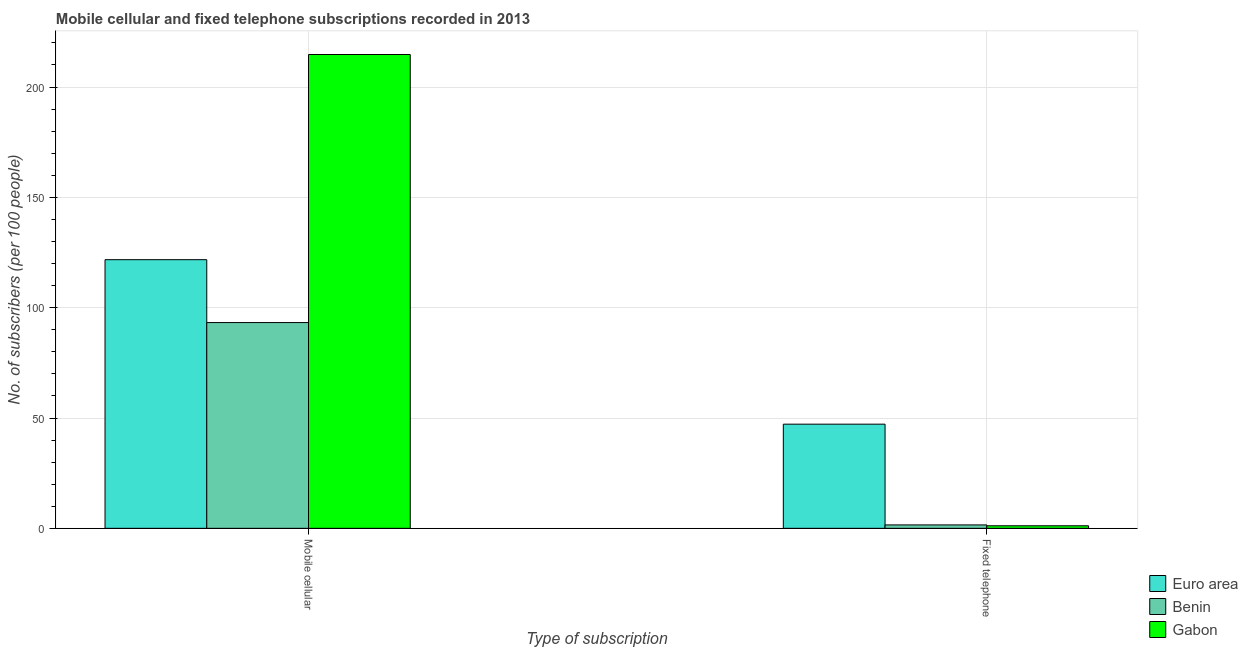Are the number of bars per tick equal to the number of legend labels?
Give a very brief answer. Yes. Are the number of bars on each tick of the X-axis equal?
Provide a short and direct response. Yes. How many bars are there on the 2nd tick from the left?
Your response must be concise. 3. What is the label of the 2nd group of bars from the left?
Provide a short and direct response. Fixed telephone. What is the number of fixed telephone subscribers in Benin?
Provide a short and direct response. 1.54. Across all countries, what is the maximum number of fixed telephone subscribers?
Provide a short and direct response. 47.21. Across all countries, what is the minimum number of fixed telephone subscribers?
Offer a terse response. 1.15. In which country was the number of fixed telephone subscribers maximum?
Your answer should be very brief. Euro area. In which country was the number of mobile cellular subscribers minimum?
Make the answer very short. Benin. What is the total number of fixed telephone subscribers in the graph?
Provide a short and direct response. 49.9. What is the difference between the number of mobile cellular subscribers in Gabon and that in Benin?
Your answer should be compact. 121.49. What is the difference between the number of fixed telephone subscribers in Gabon and the number of mobile cellular subscribers in Benin?
Keep it short and to the point. -92.11. What is the average number of mobile cellular subscribers per country?
Keep it short and to the point. 143.26. What is the difference between the number of mobile cellular subscribers and number of fixed telephone subscribers in Benin?
Offer a terse response. 91.71. What is the ratio of the number of mobile cellular subscribers in Benin to that in Gabon?
Offer a very short reply. 0.43. Is the number of fixed telephone subscribers in Gabon less than that in Euro area?
Keep it short and to the point. Yes. In how many countries, is the number of fixed telephone subscribers greater than the average number of fixed telephone subscribers taken over all countries?
Provide a succinct answer. 1. What does the 2nd bar from the left in Mobile cellular represents?
Your answer should be compact. Benin. What does the 2nd bar from the right in Fixed telephone represents?
Give a very brief answer. Benin. How many bars are there?
Ensure brevity in your answer.  6. What is the difference between two consecutive major ticks on the Y-axis?
Your answer should be compact. 50. Are the values on the major ticks of Y-axis written in scientific E-notation?
Provide a succinct answer. No. Does the graph contain any zero values?
Offer a very short reply. No. Where does the legend appear in the graph?
Your response must be concise. Bottom right. How are the legend labels stacked?
Provide a short and direct response. Vertical. What is the title of the graph?
Your answer should be very brief. Mobile cellular and fixed telephone subscriptions recorded in 2013. What is the label or title of the X-axis?
Your response must be concise. Type of subscription. What is the label or title of the Y-axis?
Keep it short and to the point. No. of subscribers (per 100 people). What is the No. of subscribers (per 100 people) in Euro area in Mobile cellular?
Ensure brevity in your answer.  121.76. What is the No. of subscribers (per 100 people) of Benin in Mobile cellular?
Your answer should be very brief. 93.26. What is the No. of subscribers (per 100 people) in Gabon in Mobile cellular?
Provide a succinct answer. 214.75. What is the No. of subscribers (per 100 people) in Euro area in Fixed telephone?
Provide a short and direct response. 47.21. What is the No. of subscribers (per 100 people) of Benin in Fixed telephone?
Offer a terse response. 1.54. What is the No. of subscribers (per 100 people) in Gabon in Fixed telephone?
Give a very brief answer. 1.15. Across all Type of subscription, what is the maximum No. of subscribers (per 100 people) of Euro area?
Your answer should be compact. 121.76. Across all Type of subscription, what is the maximum No. of subscribers (per 100 people) in Benin?
Ensure brevity in your answer.  93.26. Across all Type of subscription, what is the maximum No. of subscribers (per 100 people) in Gabon?
Your response must be concise. 214.75. Across all Type of subscription, what is the minimum No. of subscribers (per 100 people) in Euro area?
Provide a short and direct response. 47.21. Across all Type of subscription, what is the minimum No. of subscribers (per 100 people) of Benin?
Provide a succinct answer. 1.54. Across all Type of subscription, what is the minimum No. of subscribers (per 100 people) in Gabon?
Provide a short and direct response. 1.15. What is the total No. of subscribers (per 100 people) of Euro area in the graph?
Your answer should be compact. 168.96. What is the total No. of subscribers (per 100 people) of Benin in the graph?
Offer a terse response. 94.8. What is the total No. of subscribers (per 100 people) in Gabon in the graph?
Your answer should be very brief. 215.9. What is the difference between the No. of subscribers (per 100 people) of Euro area in Mobile cellular and that in Fixed telephone?
Offer a very short reply. 74.55. What is the difference between the No. of subscribers (per 100 people) of Benin in Mobile cellular and that in Fixed telephone?
Provide a succinct answer. 91.71. What is the difference between the No. of subscribers (per 100 people) of Gabon in Mobile cellular and that in Fixed telephone?
Keep it short and to the point. 213.6. What is the difference between the No. of subscribers (per 100 people) of Euro area in Mobile cellular and the No. of subscribers (per 100 people) of Benin in Fixed telephone?
Ensure brevity in your answer.  120.21. What is the difference between the No. of subscribers (per 100 people) in Euro area in Mobile cellular and the No. of subscribers (per 100 people) in Gabon in Fixed telephone?
Ensure brevity in your answer.  120.61. What is the difference between the No. of subscribers (per 100 people) of Benin in Mobile cellular and the No. of subscribers (per 100 people) of Gabon in Fixed telephone?
Your response must be concise. 92.11. What is the average No. of subscribers (per 100 people) of Euro area per Type of subscription?
Keep it short and to the point. 84.48. What is the average No. of subscribers (per 100 people) in Benin per Type of subscription?
Keep it short and to the point. 47.4. What is the average No. of subscribers (per 100 people) in Gabon per Type of subscription?
Ensure brevity in your answer.  107.95. What is the difference between the No. of subscribers (per 100 people) of Euro area and No. of subscribers (per 100 people) of Benin in Mobile cellular?
Make the answer very short. 28.5. What is the difference between the No. of subscribers (per 100 people) of Euro area and No. of subscribers (per 100 people) of Gabon in Mobile cellular?
Ensure brevity in your answer.  -92.99. What is the difference between the No. of subscribers (per 100 people) in Benin and No. of subscribers (per 100 people) in Gabon in Mobile cellular?
Your answer should be compact. -121.49. What is the difference between the No. of subscribers (per 100 people) of Euro area and No. of subscribers (per 100 people) of Benin in Fixed telephone?
Give a very brief answer. 45.66. What is the difference between the No. of subscribers (per 100 people) of Euro area and No. of subscribers (per 100 people) of Gabon in Fixed telephone?
Provide a short and direct response. 46.05. What is the difference between the No. of subscribers (per 100 people) in Benin and No. of subscribers (per 100 people) in Gabon in Fixed telephone?
Offer a terse response. 0.39. What is the ratio of the No. of subscribers (per 100 people) in Euro area in Mobile cellular to that in Fixed telephone?
Make the answer very short. 2.58. What is the ratio of the No. of subscribers (per 100 people) of Benin in Mobile cellular to that in Fixed telephone?
Provide a short and direct response. 60.38. What is the ratio of the No. of subscribers (per 100 people) in Gabon in Mobile cellular to that in Fixed telephone?
Offer a terse response. 186.47. What is the difference between the highest and the second highest No. of subscribers (per 100 people) of Euro area?
Provide a succinct answer. 74.55. What is the difference between the highest and the second highest No. of subscribers (per 100 people) of Benin?
Your answer should be compact. 91.71. What is the difference between the highest and the second highest No. of subscribers (per 100 people) in Gabon?
Offer a very short reply. 213.6. What is the difference between the highest and the lowest No. of subscribers (per 100 people) of Euro area?
Give a very brief answer. 74.55. What is the difference between the highest and the lowest No. of subscribers (per 100 people) of Benin?
Keep it short and to the point. 91.71. What is the difference between the highest and the lowest No. of subscribers (per 100 people) of Gabon?
Your answer should be very brief. 213.6. 